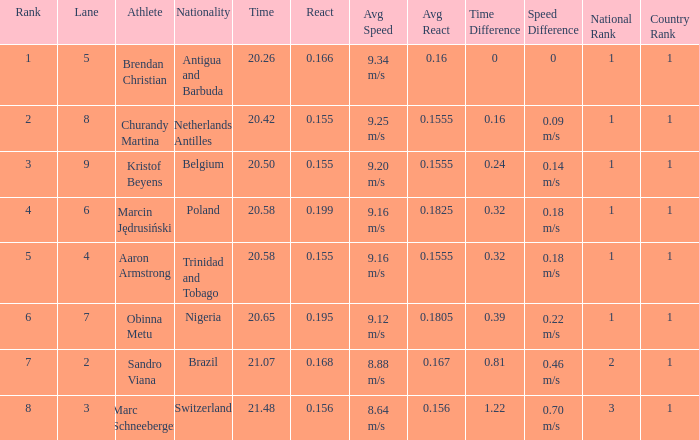I'm looking to parse the entire table for insights. Could you assist me with that? {'header': ['Rank', 'Lane', 'Athlete', 'Nationality', 'Time', 'React', 'Avg Speed', 'Avg React', 'Time Difference', 'Speed Difference', 'National Rank', 'Country Rank'], 'rows': [['1', '5', 'Brendan Christian', 'Antigua and Barbuda', '20.26', '0.166', '9.34 m/s', '0.16', '0', '0', '1', '1'], ['2', '8', 'Churandy Martina', 'Netherlands Antilles', '20.42', '0.155', '9.25 m/s', '0.1555', '0.16', '0.09 m/s', '1', '1'], ['3', '9', 'Kristof Beyens', 'Belgium', '20.50', '0.155', '9.20 m/s', '0.1555', '0.24', '0.14 m/s', '1', '1'], ['4', '6', 'Marcin Jędrusiński', 'Poland', '20.58', '0.199', '9.16 m/s', '0.1825', '0.32', '0.18 m/s', '1', '1'], ['5', '4', 'Aaron Armstrong', 'Trinidad and Tobago', '20.58', '0.155', '9.16 m/s', '0.1555', '0.32', '0.18 m/s', '1', '1'], ['6', '7', 'Obinna Metu', 'Nigeria', '20.65', '0.195', '9.12 m/s', '0.1805', '0.39', '0.22 m/s', '1', '1'], ['7', '2', 'Sandro Viana', 'Brazil', '21.07', '0.168', '8.88 m/s', '0.167', '0.81', '0.46 m/s', '2', '1'], ['8', '3', 'Marc Schneeberger', 'Switzerland', '21.48', '0.156', '8.64 m/s', '0.156', '1.22', '0.70 m/s', '3', '1']]} How much Time has a Reaction of 0.155, and an Athlete of kristof beyens, and a Rank smaller than 3? 0.0. 